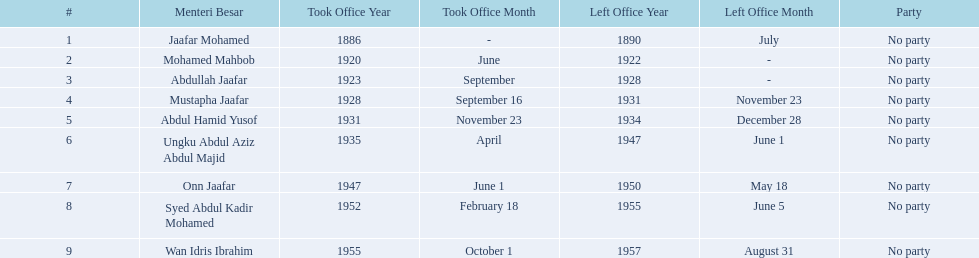What was the date the last person on the list left office? August 31, 1957. 